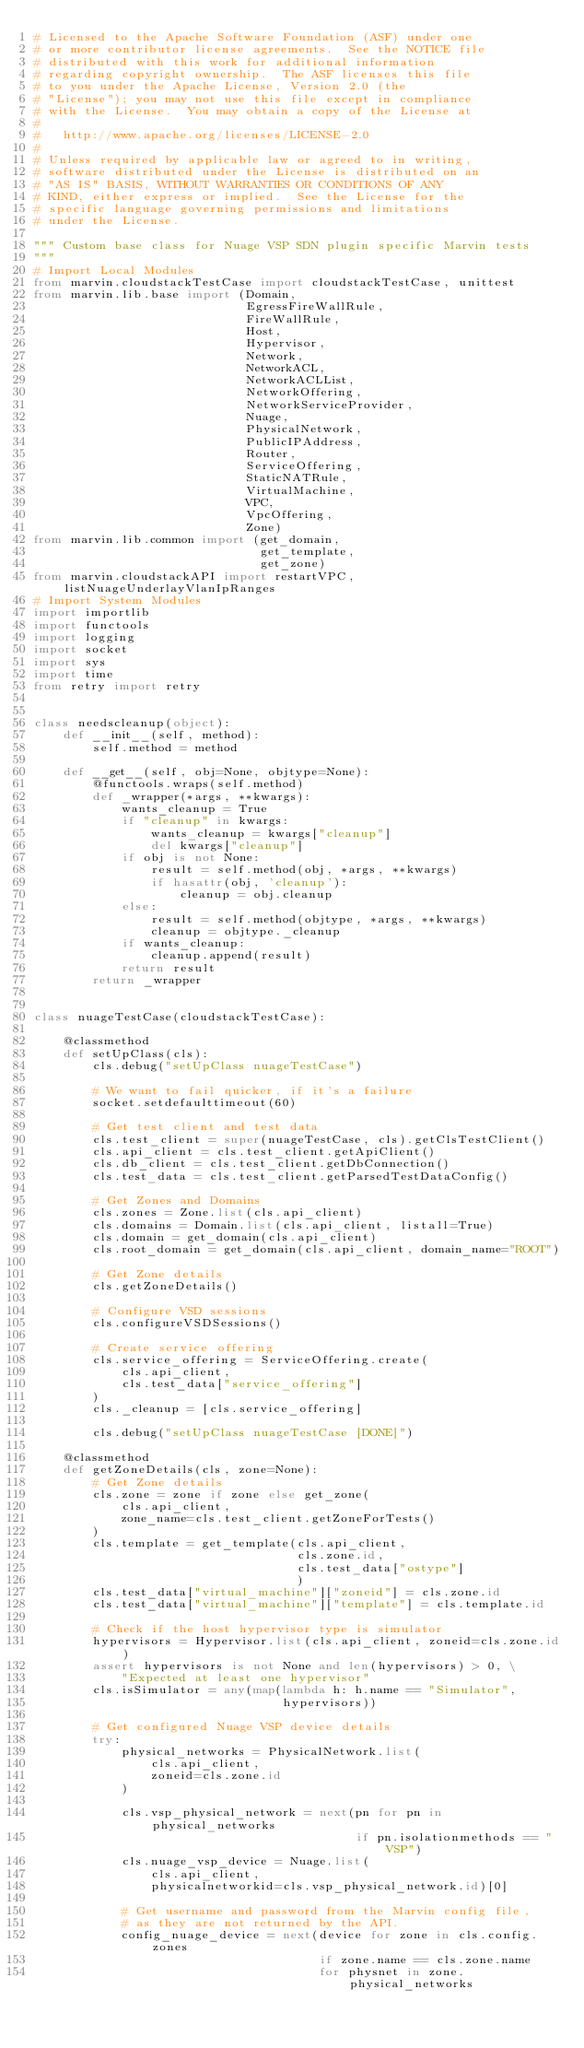<code> <loc_0><loc_0><loc_500><loc_500><_Python_># Licensed to the Apache Software Foundation (ASF) under one
# or more contributor license agreements.  See the NOTICE file
# distributed with this work for additional information
# regarding copyright ownership.  The ASF licenses this file
# to you under the Apache License, Version 2.0 (the
# "License"); you may not use this file except in compliance
# with the License.  You may obtain a copy of the License at
#
#   http://www.apache.org/licenses/LICENSE-2.0
#
# Unless required by applicable law or agreed to in writing,
# software distributed under the License is distributed on an
# "AS IS" BASIS, WITHOUT WARRANTIES OR CONDITIONS OF ANY
# KIND, either express or implied.  See the License for the
# specific language governing permissions and limitations
# under the License.

""" Custom base class for Nuage VSP SDN plugin specific Marvin tests
"""
# Import Local Modules
from marvin.cloudstackTestCase import cloudstackTestCase, unittest
from marvin.lib.base import (Domain,
                             EgressFireWallRule,
                             FireWallRule,
                             Host,
                             Hypervisor,
                             Network,
                             NetworkACL,
                             NetworkACLList,
                             NetworkOffering,
                             NetworkServiceProvider,
                             Nuage,
                             PhysicalNetwork,
                             PublicIPAddress,
                             Router,
                             ServiceOffering,
                             StaticNATRule,
                             VirtualMachine,
                             VPC,
                             VpcOffering,
                             Zone)
from marvin.lib.common import (get_domain,
                               get_template,
                               get_zone)
from marvin.cloudstackAPI import restartVPC, listNuageUnderlayVlanIpRanges
# Import System Modules
import importlib
import functools
import logging
import socket
import sys
import time
from retry import retry


class needscleanup(object):
    def __init__(self, method):
        self.method = method

    def __get__(self, obj=None, objtype=None):
        @functools.wraps(self.method)
        def _wrapper(*args, **kwargs):
            wants_cleanup = True
            if "cleanup" in kwargs:
                wants_cleanup = kwargs["cleanup"]
                del kwargs["cleanup"]
            if obj is not None:
                result = self.method(obj, *args, **kwargs)
                if hasattr(obj, 'cleanup'):
                    cleanup = obj.cleanup
            else:
                result = self.method(objtype, *args, **kwargs)
                cleanup = objtype._cleanup
            if wants_cleanup:
                cleanup.append(result)
            return result
        return _wrapper


class nuageTestCase(cloudstackTestCase):

    @classmethod
    def setUpClass(cls):
        cls.debug("setUpClass nuageTestCase")

        # We want to fail quicker, if it's a failure
        socket.setdefaulttimeout(60)

        # Get test client and test data
        cls.test_client = super(nuageTestCase, cls).getClsTestClient()
        cls.api_client = cls.test_client.getApiClient()
        cls.db_client = cls.test_client.getDbConnection()
        cls.test_data = cls.test_client.getParsedTestDataConfig()

        # Get Zones and Domains
        cls.zones = Zone.list(cls.api_client)
        cls.domains = Domain.list(cls.api_client, listall=True)
        cls.domain = get_domain(cls.api_client)
        cls.root_domain = get_domain(cls.api_client, domain_name="ROOT")

        # Get Zone details
        cls.getZoneDetails()

        # Configure VSD sessions
        cls.configureVSDSessions()

        # Create service offering
        cls.service_offering = ServiceOffering.create(
            cls.api_client,
            cls.test_data["service_offering"]
        )
        cls._cleanup = [cls.service_offering]

        cls.debug("setUpClass nuageTestCase [DONE]")

    @classmethod
    def getZoneDetails(cls, zone=None):
        # Get Zone details
        cls.zone = zone if zone else get_zone(
            cls.api_client,
            zone_name=cls.test_client.getZoneForTests()
        )
        cls.template = get_template(cls.api_client,
                                    cls.zone.id,
                                    cls.test_data["ostype"]
                                    )
        cls.test_data["virtual_machine"]["zoneid"] = cls.zone.id
        cls.test_data["virtual_machine"]["template"] = cls.template.id

        # Check if the host hypervisor type is simulator
        hypervisors = Hypervisor.list(cls.api_client, zoneid=cls.zone.id)
        assert hypervisors is not None and len(hypervisors) > 0, \
            "Expected at least one hypervisor"
        cls.isSimulator = any(map(lambda h: h.name == "Simulator",
                                  hypervisors))

        # Get configured Nuage VSP device details
        try:
            physical_networks = PhysicalNetwork.list(
                cls.api_client,
                zoneid=cls.zone.id
            )

            cls.vsp_physical_network = next(pn for pn in physical_networks
                                            if pn.isolationmethods == "VSP")
            cls.nuage_vsp_device = Nuage.list(
                cls.api_client,
                physicalnetworkid=cls.vsp_physical_network.id)[0]

            # Get username and password from the Marvin config file,
            # as they are not returned by the API.
            config_nuage_device = next(device for zone in cls.config.zones
                                       if zone.name == cls.zone.name
                                       for physnet in zone.physical_networks</code> 